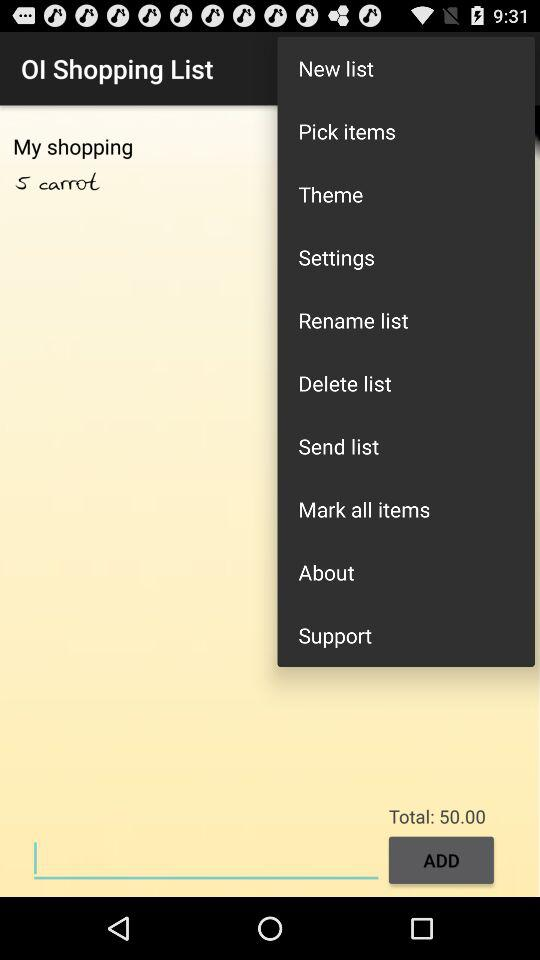What is the total amount? The total amount is 50.00. 